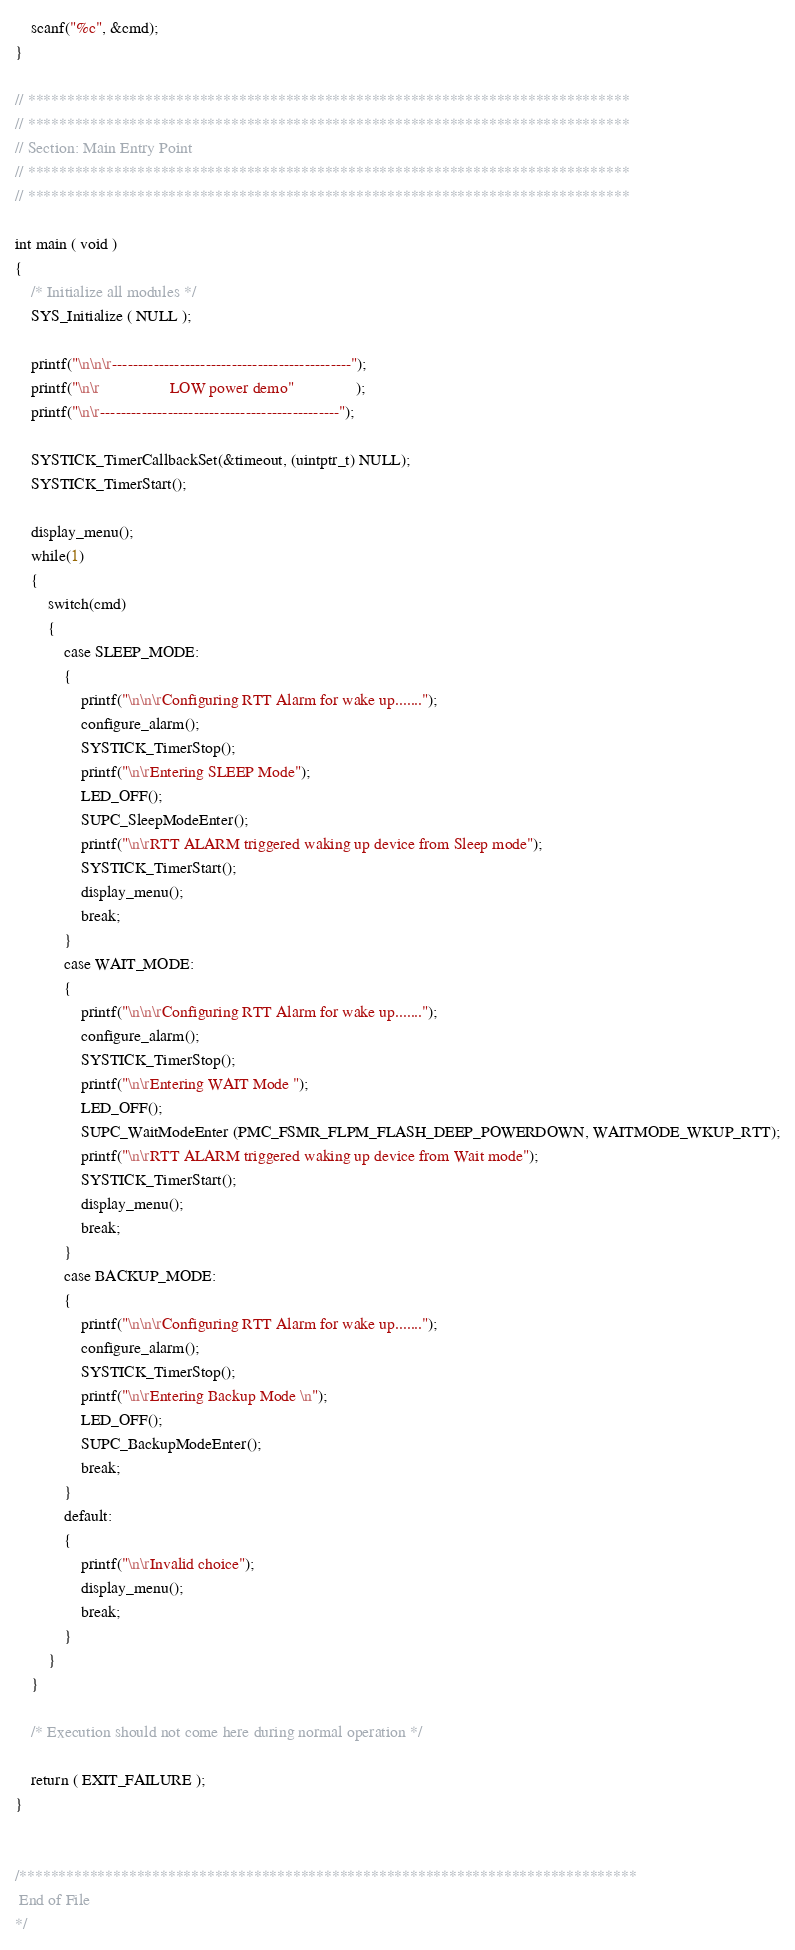<code> <loc_0><loc_0><loc_500><loc_500><_C_>    scanf("%c", &cmd);
}

// *****************************************************************************
// *****************************************************************************
// Section: Main Entry Point
// *****************************************************************************
// *****************************************************************************

int main ( void )
{
    /* Initialize all modules */
    SYS_Initialize ( NULL );

    printf("\n\n\r----------------------------------------------");
    printf("\n\r                 LOW power demo"               );
    printf("\n\r----------------------------------------------"); 
    
    SYSTICK_TimerCallbackSet(&timeout, (uintptr_t) NULL);
    SYSTICK_TimerStart();
    
    display_menu();
    while(1)
    {
        switch(cmd)
        {
            case SLEEP_MODE:
            {
                printf("\n\n\rConfiguring RTT Alarm for wake up.......");
                configure_alarm();
                SYSTICK_TimerStop();
                printf("\n\rEntering SLEEP Mode");
                LED_OFF();
                SUPC_SleepModeEnter();
                printf("\n\rRTT ALARM triggered waking up device from Sleep mode");
                SYSTICK_TimerStart();
                display_menu();
                break;
            }
            case WAIT_MODE:
            {
                printf("\n\n\rConfiguring RTT Alarm for wake up.......");
                configure_alarm();
                SYSTICK_TimerStop();
                printf("\n\rEntering WAIT Mode ");
                LED_OFF();
                SUPC_WaitModeEnter (PMC_FSMR_FLPM_FLASH_DEEP_POWERDOWN, WAITMODE_WKUP_RTT);
                printf("\n\rRTT ALARM triggered waking up device from Wait mode");
                SYSTICK_TimerStart();
                display_menu();
                break;
            }
            case BACKUP_MODE:
            {
                printf("\n\n\rConfiguring RTT Alarm for wake up.......");
                configure_alarm();
                SYSTICK_TimerStop();
                printf("\n\rEntering Backup Mode \n");
                LED_OFF();
                SUPC_BackupModeEnter();
                break;
            }
            default:
            {
                printf("\n\rInvalid choice");
                display_menu();
                break;
            }
        } 
    }

    /* Execution should not come here during normal operation */

    return ( EXIT_FAILURE );
}


/*******************************************************************************
 End of File
*/

</code> 